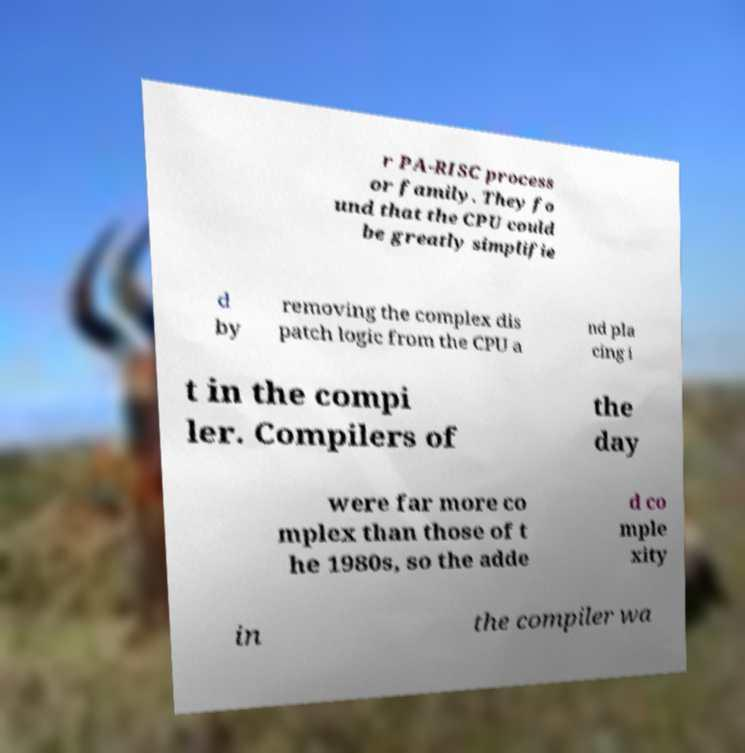Can you accurately transcribe the text from the provided image for me? r PA-RISC process or family. They fo und that the CPU could be greatly simplifie d by removing the complex dis patch logic from the CPU a nd pla cing i t in the compi ler. Compilers of the day were far more co mplex than those of t he 1980s, so the adde d co mple xity in the compiler wa 